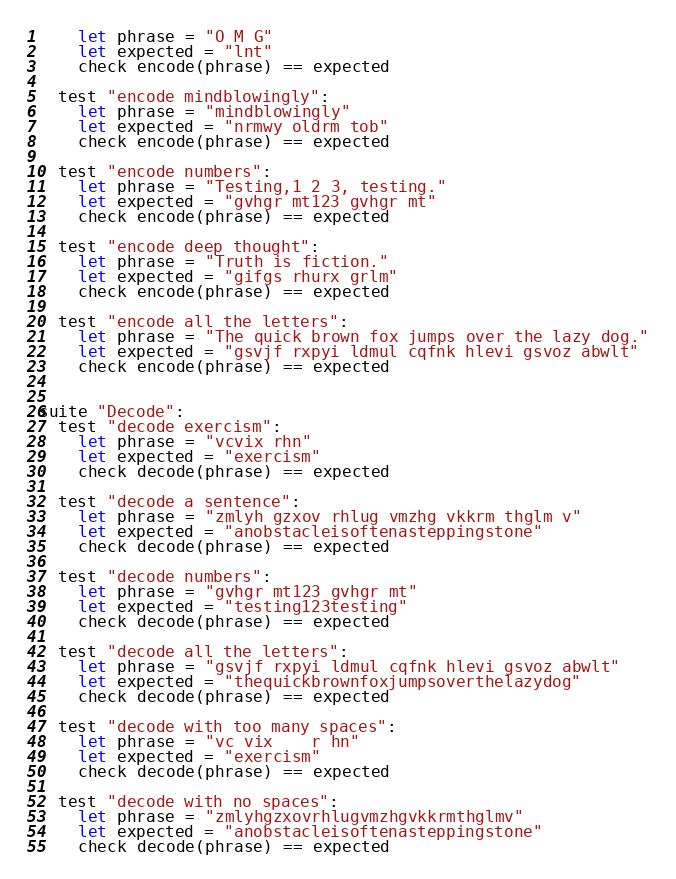Convert code to text. <code><loc_0><loc_0><loc_500><loc_500><_Nim_>    let phrase = "O M G"
    let expected = "lnt"
    check encode(phrase) == expected

  test "encode mindblowingly":
    let phrase = "mindblowingly"
    let expected = "nrmwy oldrm tob"
    check encode(phrase) == expected

  test "encode numbers":
    let phrase = "Testing,1 2 3, testing."
    let expected = "gvhgr mt123 gvhgr mt"
    check encode(phrase) == expected

  test "encode deep thought":
    let phrase = "Truth is fiction."
    let expected = "gifgs rhurx grlm"
    check encode(phrase) == expected

  test "encode all the letters":
    let phrase = "The quick brown fox jumps over the lazy dog."
    let expected = "gsvjf rxpyi ldmul cqfnk hlevi gsvoz abwlt"
    check encode(phrase) == expected


suite "Decode":
  test "decode exercism":
    let phrase = "vcvix rhn"
    let expected = "exercism"
    check decode(phrase) == expected

  test "decode a sentence":
    let phrase = "zmlyh gzxov rhlug vmzhg vkkrm thglm v"
    let expected = "anobstacleisoftenasteppingstone"
    check decode(phrase) == expected

  test "decode numbers":
    let phrase = "gvhgr mt123 gvhgr mt"
    let expected = "testing123testing"
    check decode(phrase) == expected

  test "decode all the letters":
    let phrase = "gsvjf rxpyi ldmul cqfnk hlevi gsvoz abwlt"
    let expected = "thequickbrownfoxjumpsoverthelazydog"
    check decode(phrase) == expected

  test "decode with too many spaces":
    let phrase = "vc vix    r hn"
    let expected = "exercism"
    check decode(phrase) == expected

  test "decode with no spaces":
    let phrase = "zmlyhgzxovrhlugvmzhgvkkrmthglmv"
    let expected = "anobstacleisoftenasteppingstone"
    check decode(phrase) == expected
</code> 